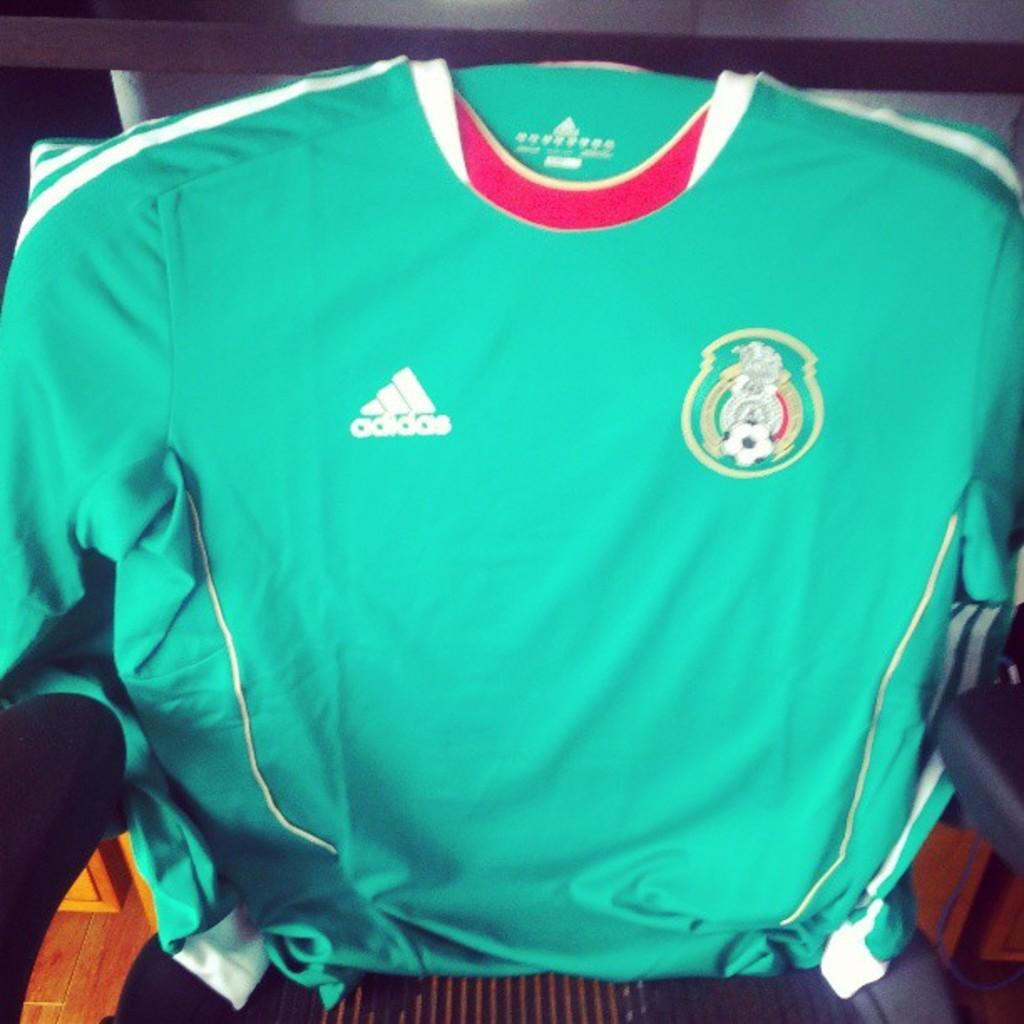<image>
Relay a brief, clear account of the picture shown. addidas jersey is sitting in a chair that is for soccer 